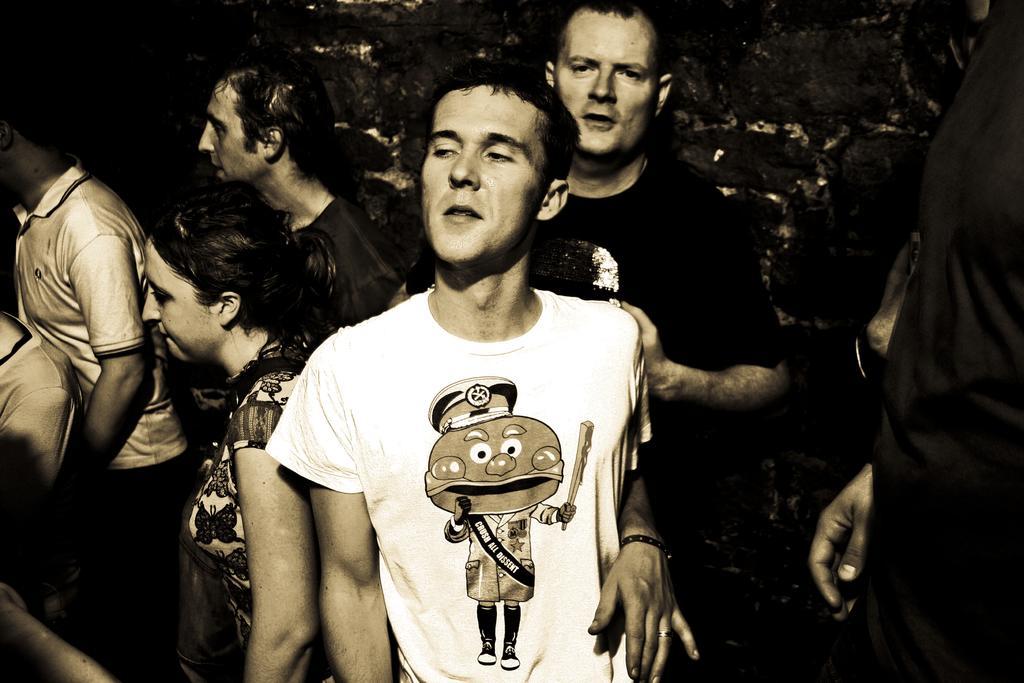Can you describe this image briefly? In this picture there are people in the image. 